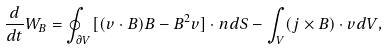<formula> <loc_0><loc_0><loc_500><loc_500>\frac { d } { d t } W _ { B } = \oint _ { \partial V } [ ( { v } \cdot { B } ) { B } - B ^ { 2 } { v } ] \cdot { n } d S - \int _ { V } ( { j } \times { B } ) \cdot { v } d V ,</formula> 